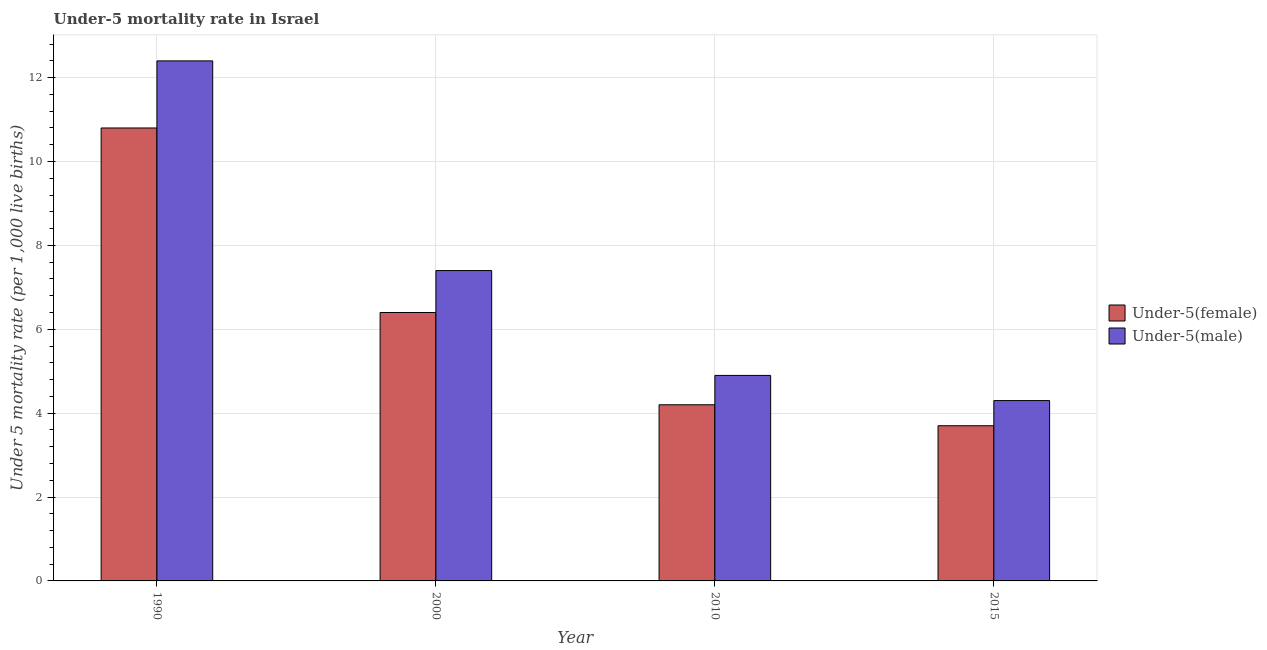How many different coloured bars are there?
Offer a very short reply. 2. How many groups of bars are there?
Give a very brief answer. 4. Are the number of bars per tick equal to the number of legend labels?
Your answer should be compact. Yes. Are the number of bars on each tick of the X-axis equal?
Offer a terse response. Yes. How many bars are there on the 3rd tick from the right?
Give a very brief answer. 2. In how many cases, is the number of bars for a given year not equal to the number of legend labels?
Your answer should be very brief. 0. In which year was the under-5 female mortality rate maximum?
Make the answer very short. 1990. In which year was the under-5 female mortality rate minimum?
Keep it short and to the point. 2015. What is the total under-5 male mortality rate in the graph?
Your answer should be very brief. 29. What is the difference between the under-5 female mortality rate in 2000 and that in 2010?
Offer a terse response. 2.2. What is the difference between the under-5 male mortality rate in 2015 and the under-5 female mortality rate in 2000?
Ensure brevity in your answer.  -3.1. What is the average under-5 male mortality rate per year?
Make the answer very short. 7.25. In how many years, is the under-5 female mortality rate greater than 2.4?
Your answer should be very brief. 4. What is the ratio of the under-5 male mortality rate in 1990 to that in 2015?
Offer a very short reply. 2.88. Is the difference between the under-5 male mortality rate in 2000 and 2010 greater than the difference between the under-5 female mortality rate in 2000 and 2010?
Your response must be concise. No. What is the difference between the highest and the second highest under-5 female mortality rate?
Keep it short and to the point. 4.4. What is the difference between the highest and the lowest under-5 female mortality rate?
Make the answer very short. 7.1. Is the sum of the under-5 female mortality rate in 2010 and 2015 greater than the maximum under-5 male mortality rate across all years?
Your response must be concise. No. What does the 1st bar from the left in 2010 represents?
Offer a terse response. Under-5(female). What does the 1st bar from the right in 2010 represents?
Your answer should be very brief. Under-5(male). How many bars are there?
Keep it short and to the point. 8. How many years are there in the graph?
Provide a short and direct response. 4. What is the difference between two consecutive major ticks on the Y-axis?
Your response must be concise. 2. Where does the legend appear in the graph?
Keep it short and to the point. Center right. How many legend labels are there?
Give a very brief answer. 2. What is the title of the graph?
Ensure brevity in your answer.  Under-5 mortality rate in Israel. What is the label or title of the X-axis?
Your response must be concise. Year. What is the label or title of the Y-axis?
Provide a succinct answer. Under 5 mortality rate (per 1,0 live births). What is the Under 5 mortality rate (per 1,000 live births) in Under-5(female) in 1990?
Ensure brevity in your answer.  10.8. What is the Under 5 mortality rate (per 1,000 live births) of Under-5(male) in 2000?
Offer a terse response. 7.4. Across all years, what is the minimum Under 5 mortality rate (per 1,000 live births) of Under-5(male)?
Your answer should be compact. 4.3. What is the total Under 5 mortality rate (per 1,000 live births) of Under-5(female) in the graph?
Your response must be concise. 25.1. What is the difference between the Under 5 mortality rate (per 1,000 live births) in Under-5(female) in 1990 and that in 2000?
Make the answer very short. 4.4. What is the difference between the Under 5 mortality rate (per 1,000 live births) of Under-5(male) in 1990 and that in 2000?
Ensure brevity in your answer.  5. What is the difference between the Under 5 mortality rate (per 1,000 live births) in Under-5(male) in 1990 and that in 2015?
Give a very brief answer. 8.1. What is the difference between the Under 5 mortality rate (per 1,000 live births) in Under-5(female) in 2000 and that in 2010?
Keep it short and to the point. 2.2. What is the difference between the Under 5 mortality rate (per 1,000 live births) of Under-5(female) in 2000 and that in 2015?
Your response must be concise. 2.7. What is the difference between the Under 5 mortality rate (per 1,000 live births) of Under-5(male) in 2000 and that in 2015?
Make the answer very short. 3.1. What is the difference between the Under 5 mortality rate (per 1,000 live births) in Under-5(female) in 2010 and that in 2015?
Give a very brief answer. 0.5. What is the difference between the Under 5 mortality rate (per 1,000 live births) in Under-5(female) in 1990 and the Under 5 mortality rate (per 1,000 live births) in Under-5(male) in 2000?
Make the answer very short. 3.4. What is the difference between the Under 5 mortality rate (per 1,000 live births) of Under-5(female) in 2000 and the Under 5 mortality rate (per 1,000 live births) of Under-5(male) in 2010?
Offer a terse response. 1.5. What is the difference between the Under 5 mortality rate (per 1,000 live births) in Under-5(female) in 2010 and the Under 5 mortality rate (per 1,000 live births) in Under-5(male) in 2015?
Your answer should be compact. -0.1. What is the average Under 5 mortality rate (per 1,000 live births) in Under-5(female) per year?
Your answer should be very brief. 6.28. What is the average Under 5 mortality rate (per 1,000 live births) in Under-5(male) per year?
Your response must be concise. 7.25. In the year 2000, what is the difference between the Under 5 mortality rate (per 1,000 live births) of Under-5(female) and Under 5 mortality rate (per 1,000 live births) of Under-5(male)?
Keep it short and to the point. -1. In the year 2010, what is the difference between the Under 5 mortality rate (per 1,000 live births) in Under-5(female) and Under 5 mortality rate (per 1,000 live births) in Under-5(male)?
Give a very brief answer. -0.7. What is the ratio of the Under 5 mortality rate (per 1,000 live births) in Under-5(female) in 1990 to that in 2000?
Your response must be concise. 1.69. What is the ratio of the Under 5 mortality rate (per 1,000 live births) in Under-5(male) in 1990 to that in 2000?
Offer a terse response. 1.68. What is the ratio of the Under 5 mortality rate (per 1,000 live births) in Under-5(female) in 1990 to that in 2010?
Offer a terse response. 2.57. What is the ratio of the Under 5 mortality rate (per 1,000 live births) of Under-5(male) in 1990 to that in 2010?
Offer a very short reply. 2.53. What is the ratio of the Under 5 mortality rate (per 1,000 live births) of Under-5(female) in 1990 to that in 2015?
Provide a short and direct response. 2.92. What is the ratio of the Under 5 mortality rate (per 1,000 live births) in Under-5(male) in 1990 to that in 2015?
Provide a short and direct response. 2.88. What is the ratio of the Under 5 mortality rate (per 1,000 live births) of Under-5(female) in 2000 to that in 2010?
Your answer should be compact. 1.52. What is the ratio of the Under 5 mortality rate (per 1,000 live births) in Under-5(male) in 2000 to that in 2010?
Offer a terse response. 1.51. What is the ratio of the Under 5 mortality rate (per 1,000 live births) in Under-5(female) in 2000 to that in 2015?
Keep it short and to the point. 1.73. What is the ratio of the Under 5 mortality rate (per 1,000 live births) of Under-5(male) in 2000 to that in 2015?
Your answer should be compact. 1.72. What is the ratio of the Under 5 mortality rate (per 1,000 live births) of Under-5(female) in 2010 to that in 2015?
Offer a terse response. 1.14. What is the ratio of the Under 5 mortality rate (per 1,000 live births) in Under-5(male) in 2010 to that in 2015?
Keep it short and to the point. 1.14. What is the difference between the highest and the second highest Under 5 mortality rate (per 1,000 live births) of Under-5(male)?
Ensure brevity in your answer.  5. What is the difference between the highest and the lowest Under 5 mortality rate (per 1,000 live births) in Under-5(female)?
Your answer should be compact. 7.1. 